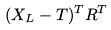<formula> <loc_0><loc_0><loc_500><loc_500>( X _ { L } - T ) ^ { T } R ^ { T }</formula> 